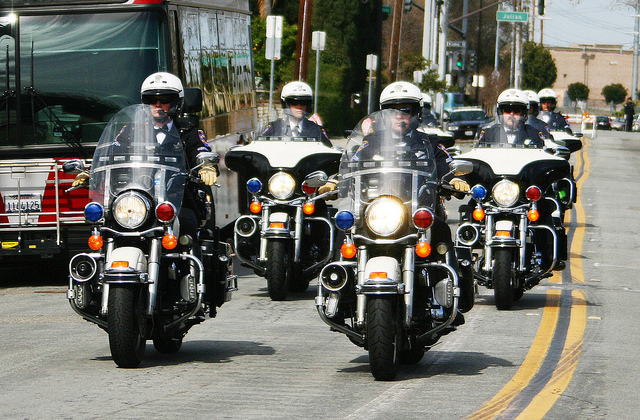<image>What are the policemen escorting? It is not clear what the policemen are escorting. It could be a bus, a funeral, or a VIP. What are the policemen escorting? I'm not sure what the policemen are escorting. It could be a bus, a funeral procession, or a VIP. 